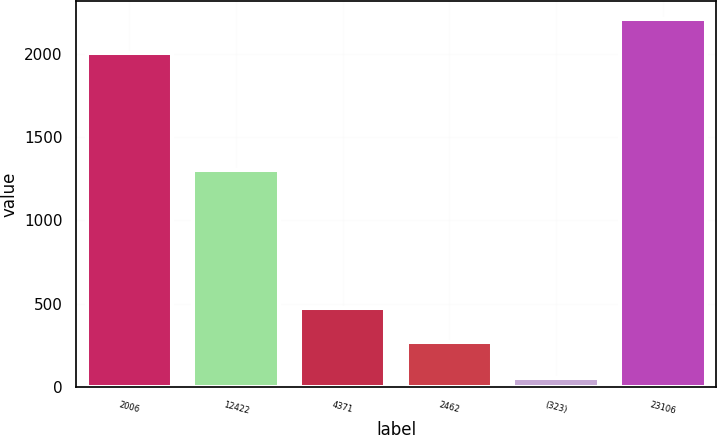<chart> <loc_0><loc_0><loc_500><loc_500><bar_chart><fcel>2006<fcel>12422<fcel>4371<fcel>2462<fcel>(323)<fcel>23106<nl><fcel>2004<fcel>1302.5<fcel>474.53<fcel>269.5<fcel>51.2<fcel>2209.03<nl></chart> 